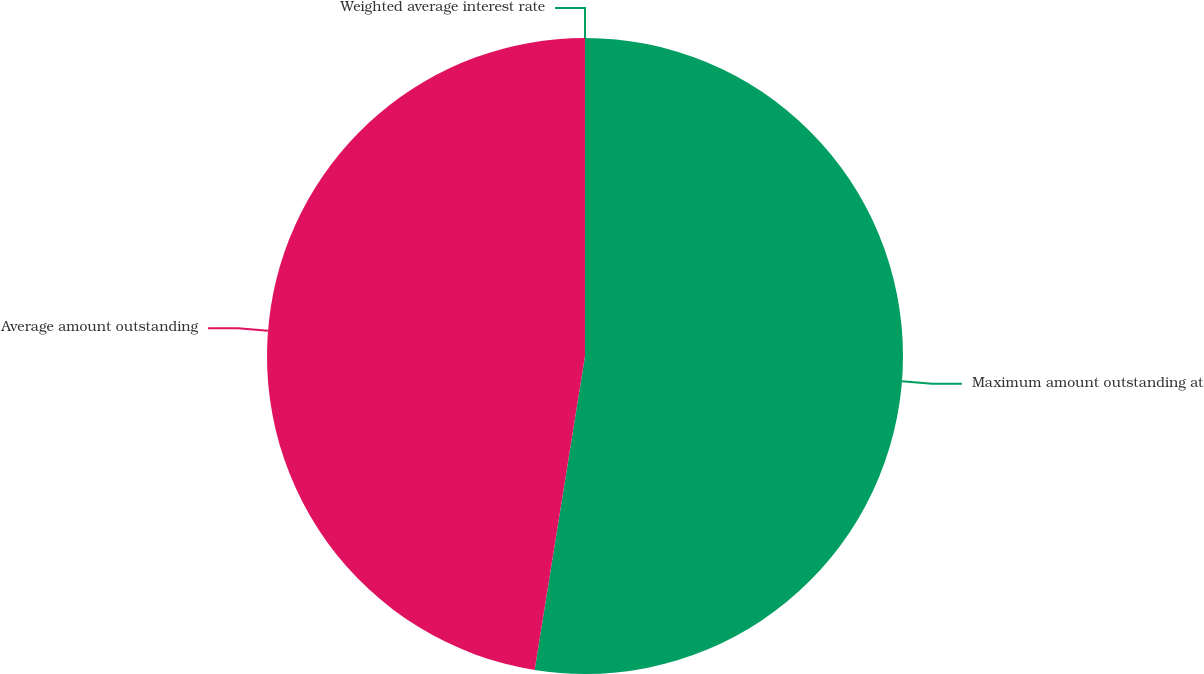<chart> <loc_0><loc_0><loc_500><loc_500><pie_chart><fcel>Maximum amount outstanding at<fcel>Average amount outstanding<fcel>Weighted average interest rate<nl><fcel>52.53%<fcel>47.47%<fcel>0.0%<nl></chart> 